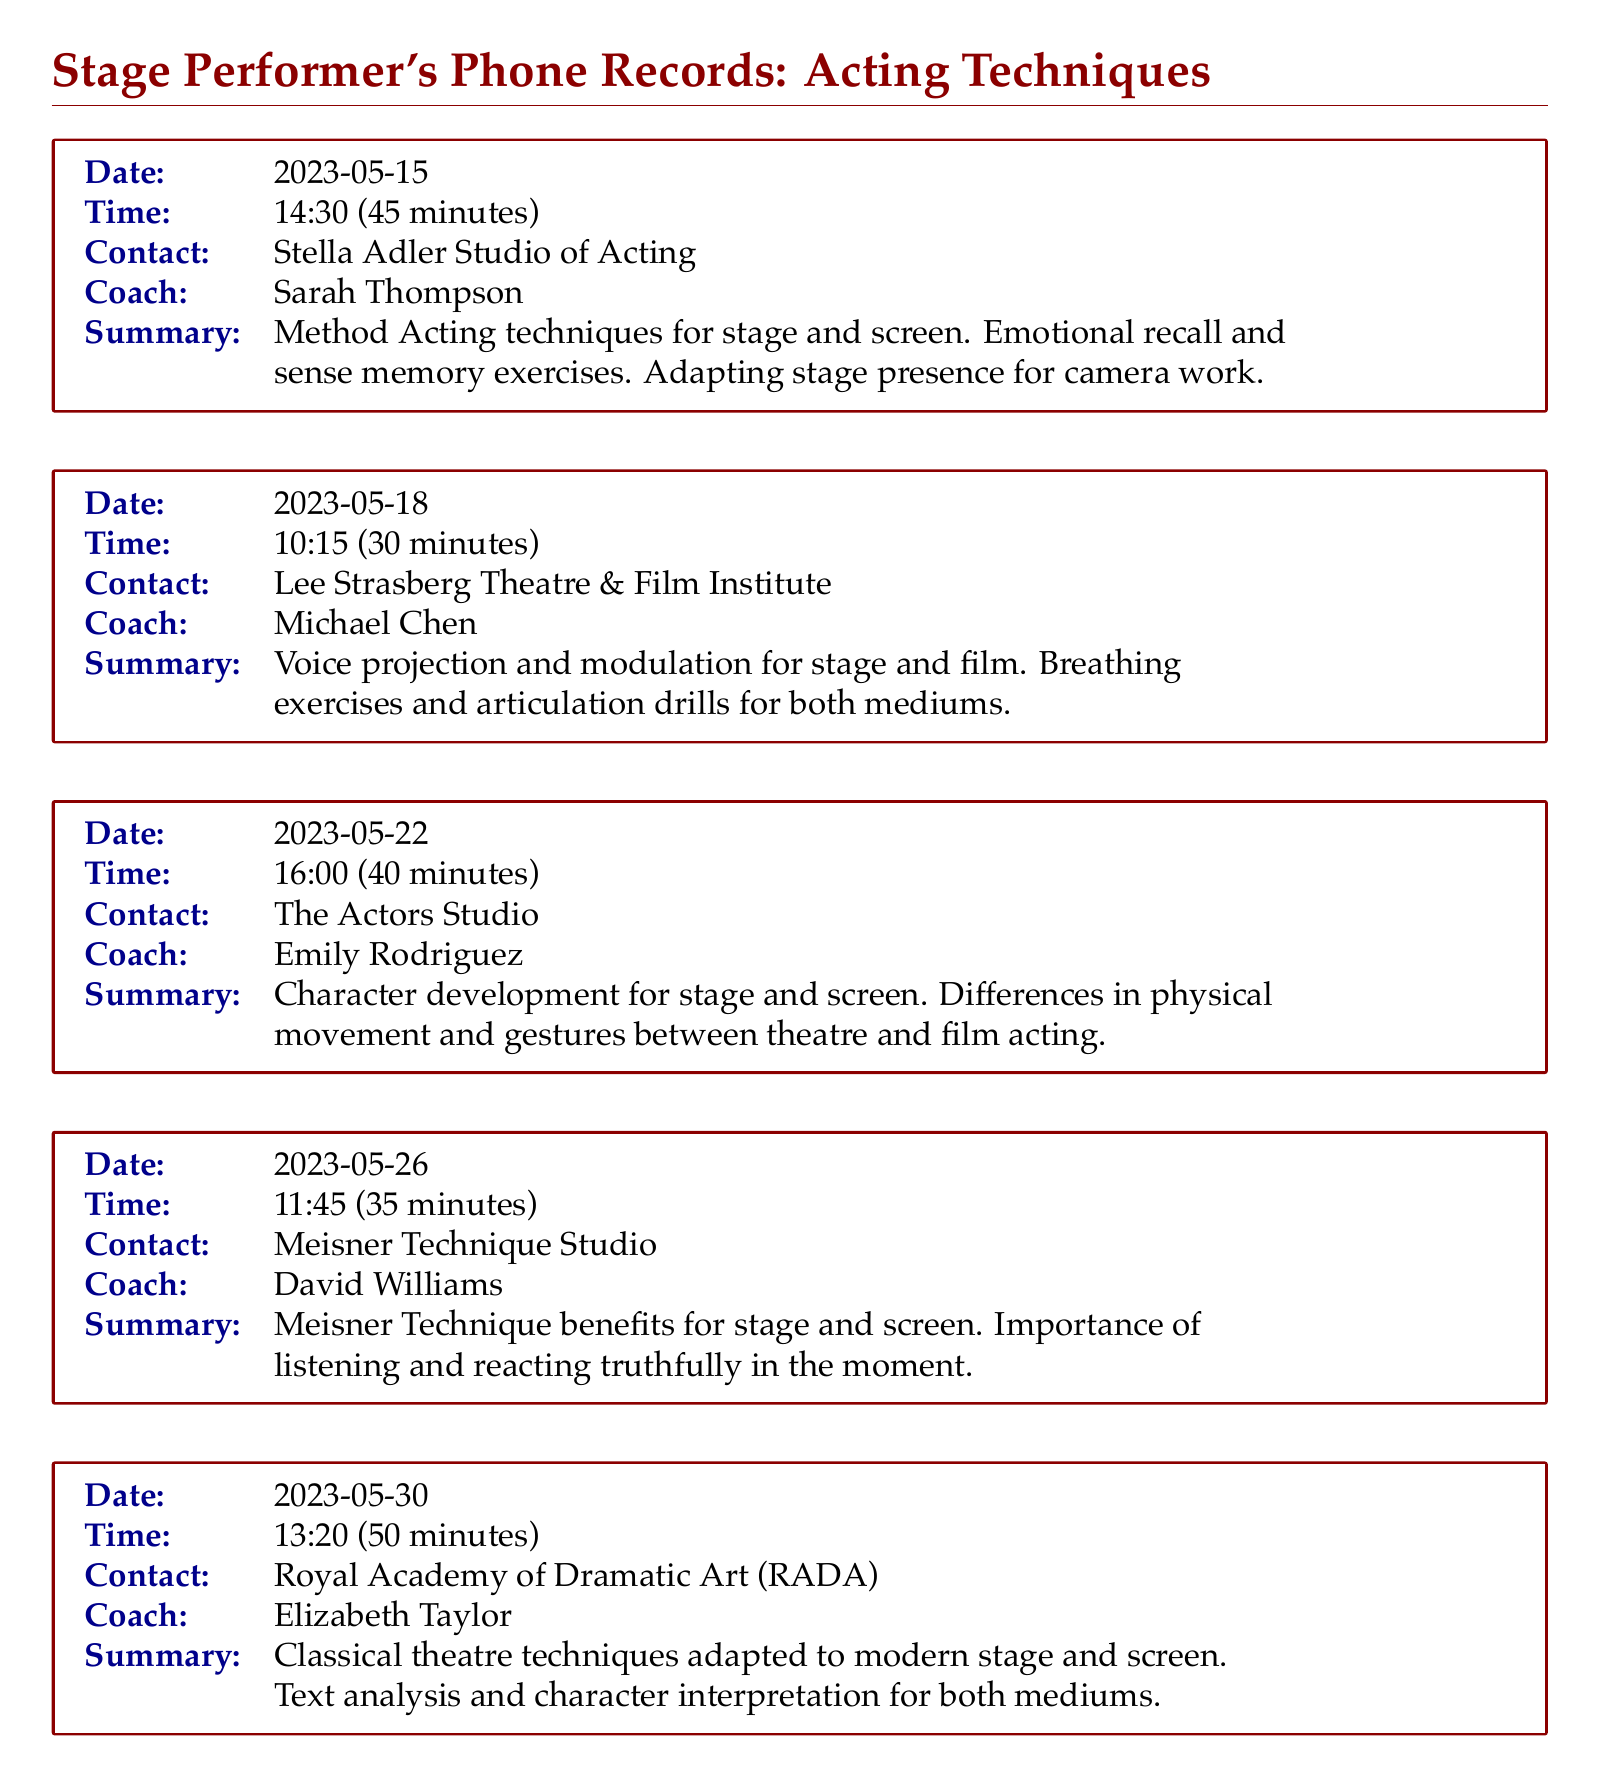What is the date of the first phone conversation? The date of the first phone conversation is listed in the document.
Answer: 2023-05-15 Who was the coach for the conversation on May 18? The document specifies the coach for each conversation along with their respective dates.
Answer: Michael Chen What technique was discussed in the conversation with Sarah Thompson? The summary for each conversation outlines the main techniques discussed with the coaches.
Answer: Method Acting techniques How long was the conversation on May 30? The duration of each conversation is indicated in the document.
Answer: 50 minutes Which institute was contacted on May 22? The document includes the names of the institutes contacted for each coaching session.
Answer: The Actors Studio What was a key focus in the conversation with David Williams? The summaries provide important focus areas for each coaching session.
Answer: Meisner Technique benefits How many minutes did the conversation with Emily Rodriguez last? Each conversation in the document specifies its duration.
Answer: 40 minutes What common theme do the coaching sessions emphasize? The document captures recurring themes in the coaching summaries.
Answer: Techniques for both stage and screen Which coaching session involved voice projection? Each entry in the document identifies different focuses of the coaching sessions.
Answer: May 18 